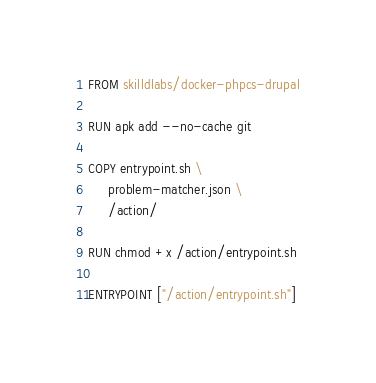<code> <loc_0><loc_0><loc_500><loc_500><_Dockerfile_>FROM skilldlabs/docker-phpcs-drupal

RUN apk add --no-cache git

COPY entrypoint.sh \
     problem-matcher.json \
     /action/

RUN chmod +x /action/entrypoint.sh

ENTRYPOINT ["/action/entrypoint.sh"]
</code> 